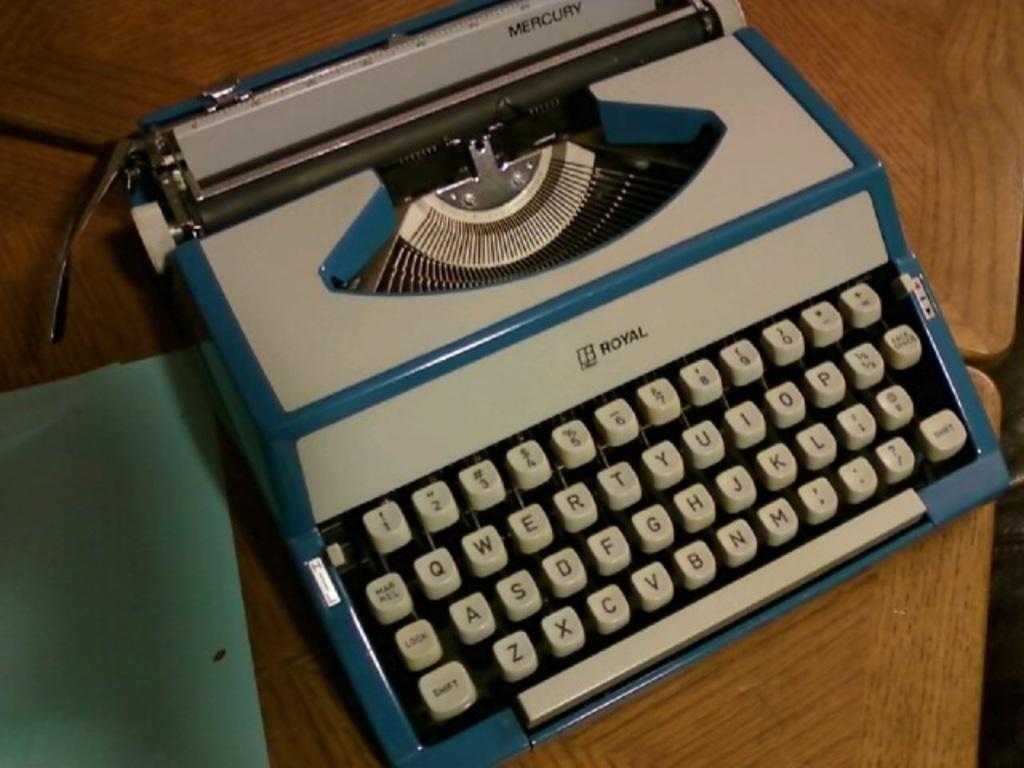What brand of typewriter is this?
Offer a terse response. Royal. 